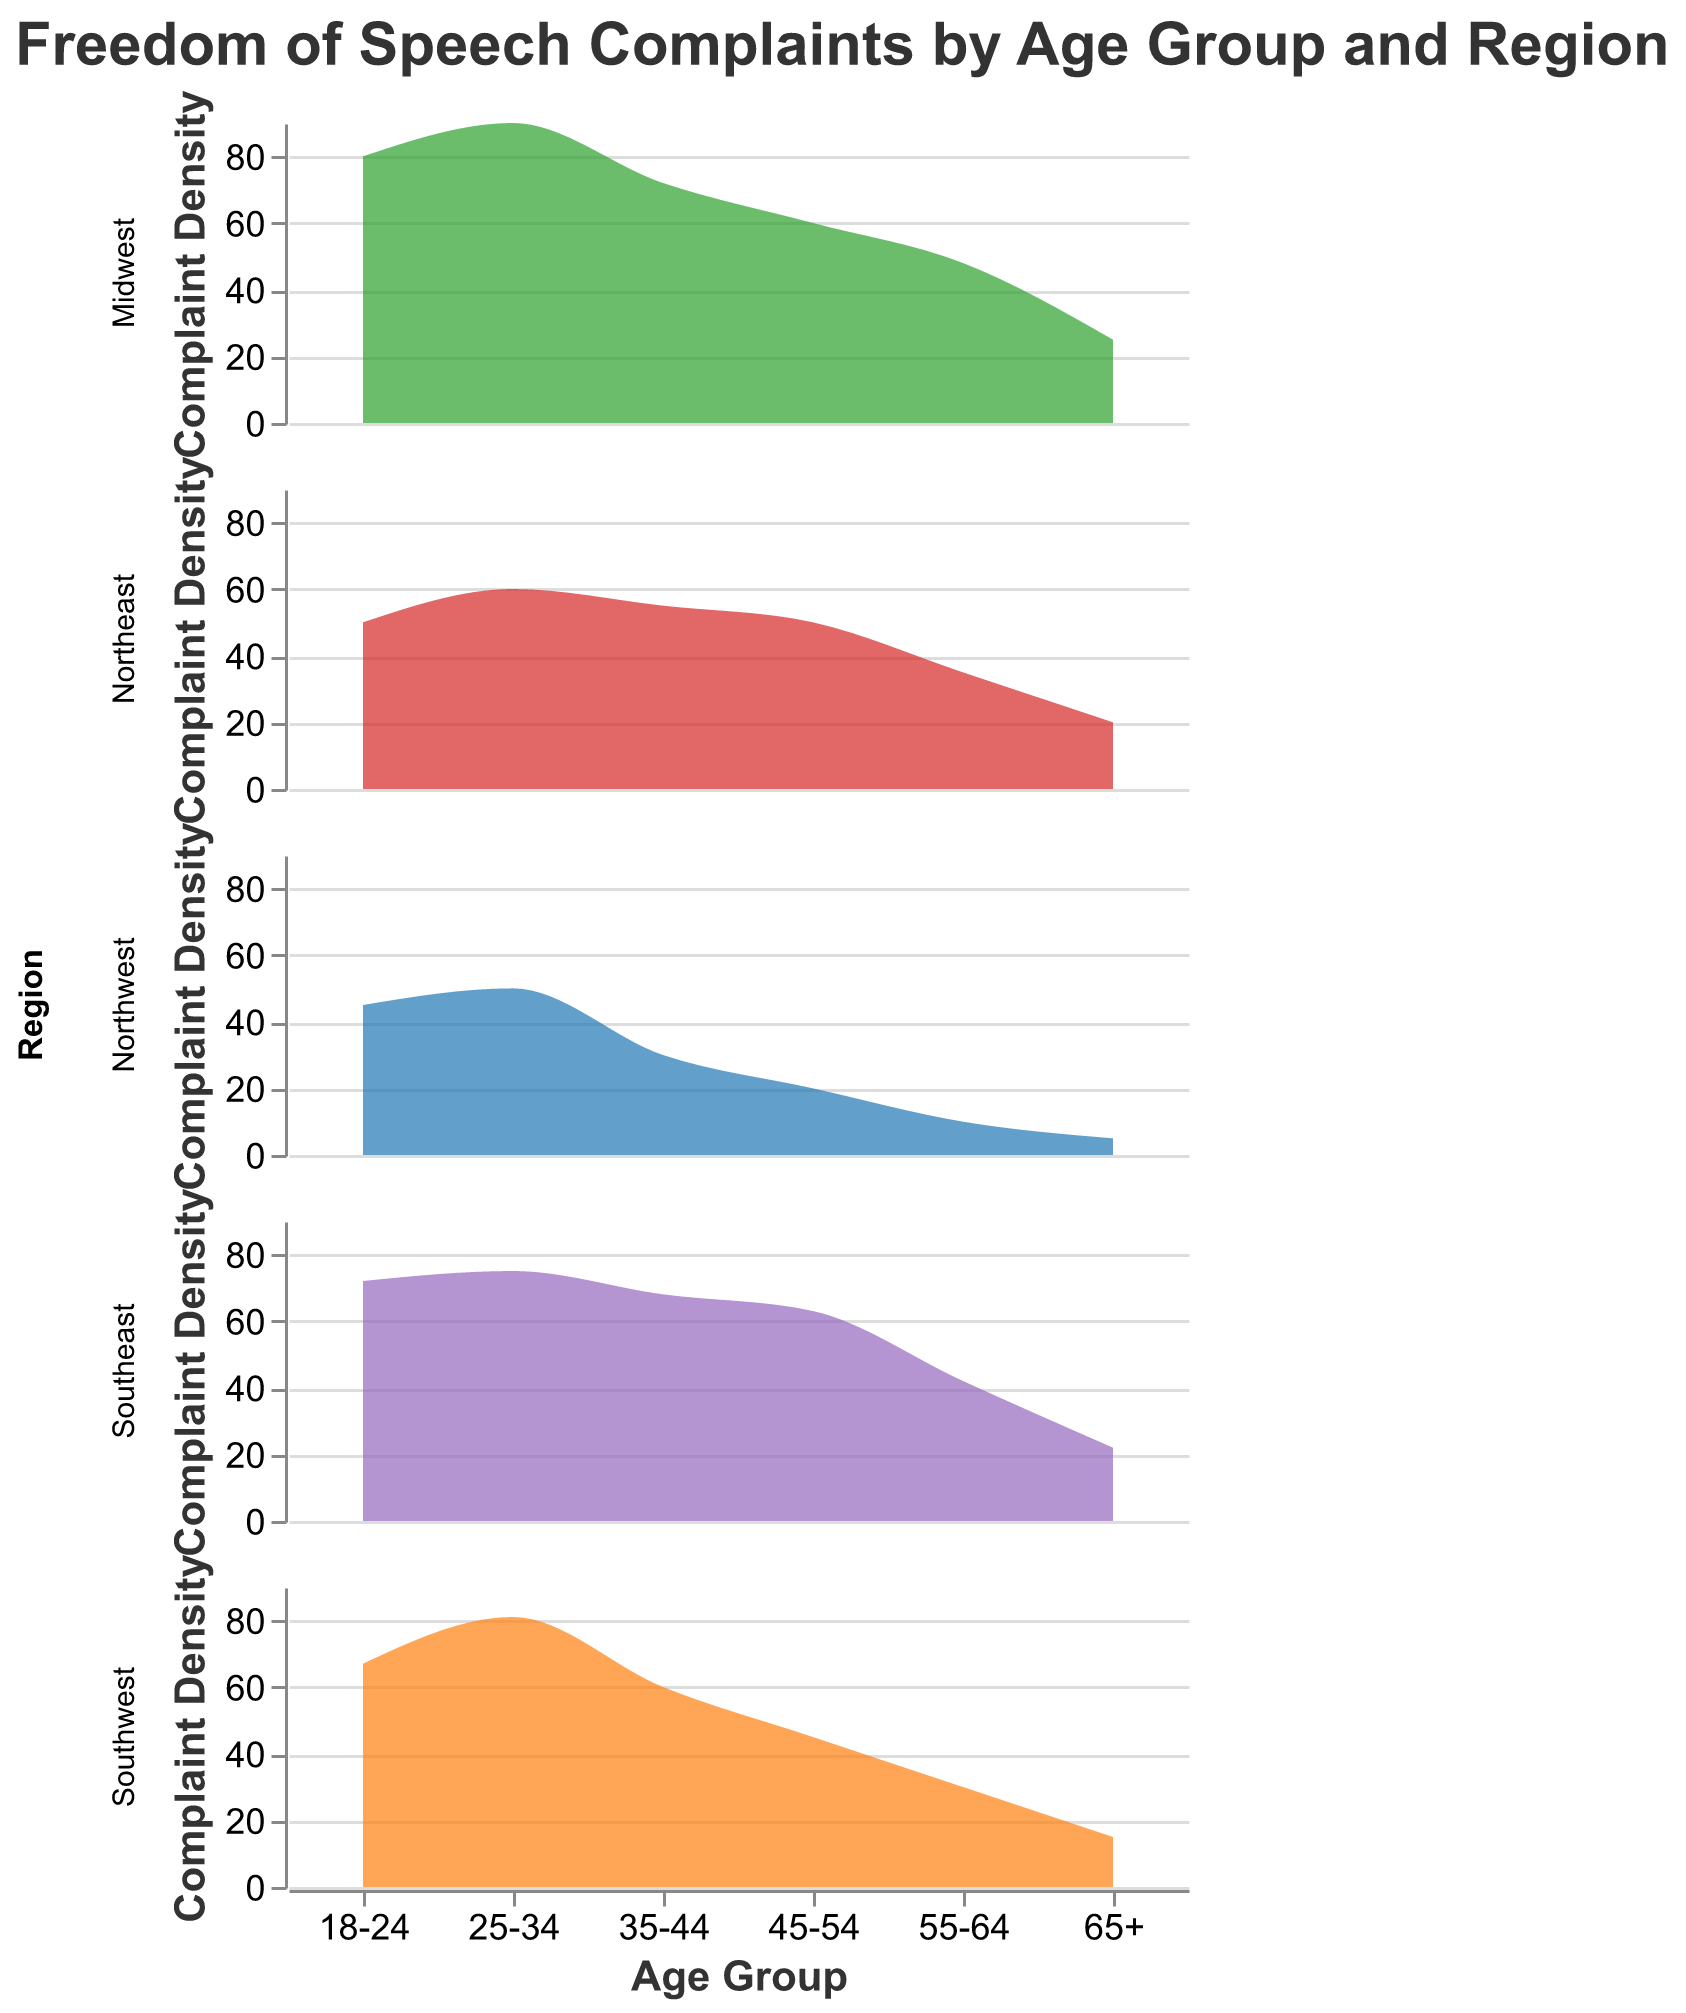What is the title of the figure? The title of the figure is usually found at the top and generally summarized the content. This figure's title is explicitly presented in the specifications.
Answer: Freedom of Speech Complaints by Age Group and Region Which age group has the highest number of complaints in the Midwest region? Look at the subplot for the Midwest region, then find the age group with the highest point on the y-axis. The highest value is for the 25-34 age group.
Answer: 25-34 What is the range of the complaint density for the Southeast region? Find the subplot for the Southeast region and identify the minimum and maximum values on the y-axis. The lowest value is 22 and the highest is 75.
Answer: 22-75 Which region has the least number of complaints for the 65+ age group? Compare the values for the 65+ age group across all regions and identify the lowest one. The Northwest has the lowest value with 5 complaints.
Answer: Northwest Are there noticeable differences in complaint density among regions for the same age group? You need to compare the trends along the y-axis for each given age group across all the subplots. Significant differences can be seen, particularly in the 18-24 and 25-34 age groups.
Answer: Yes What age group has the smallest variability in complaint density across all regions? Evaluate the consistency across all regions for each age group. The 65+ age group shows the smallest variability, with values ranging between 5 (Northwest) to 25 (Midwest).
Answer: 65+ How does the complaint trend change from age group 18-24 to 65+ in the Northeast region? Observe the complaint density curve for the Northeast region and note the trend from 18-24 to 65+. Complaints generally decrease as age increases.
Answer: Decreases Which region exhibits the highest complaint density for the age group 35-44? Look at the subplots and compare the values for the age group 35-44. The Midwest has the highest value with 72 complaints.
Answer: Midwest What is the total number of complaints for the 35-44 age group in all regions combined? Sum the complaint values for the 35-44 age group across all regions. The values are 30 (Northwest) + 60 (Southwest) + 72 (Midwest) + 55 (Northeast) + 68 (Southeast), giving a total of 285.
Answer: 285 